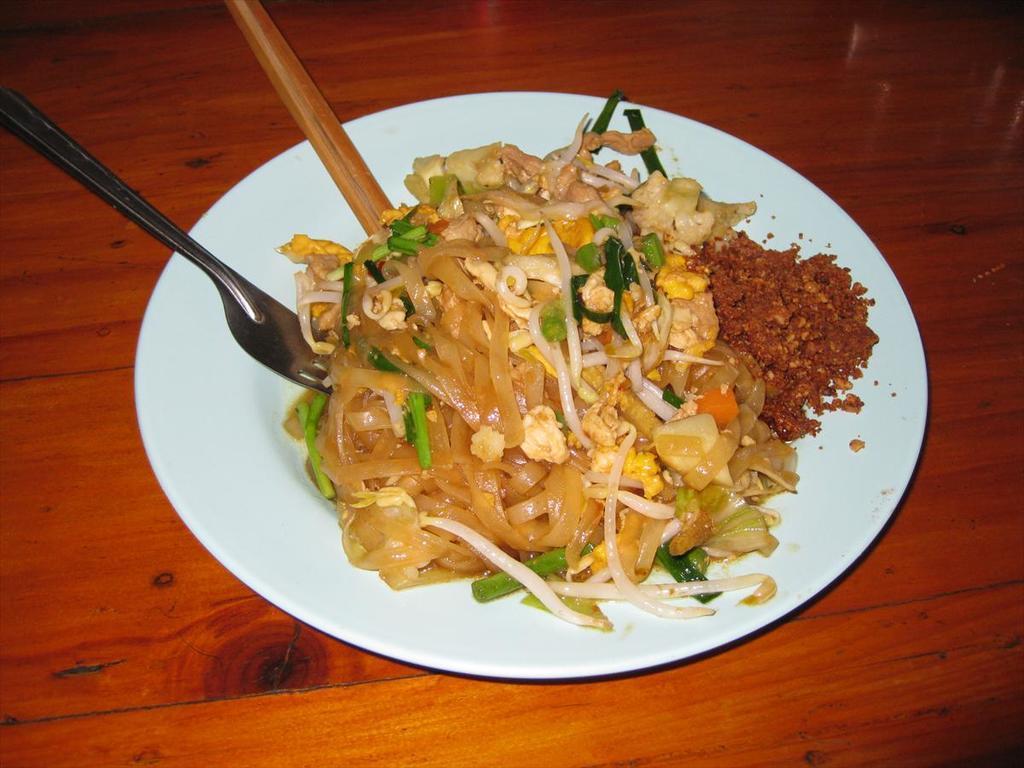Can you describe this image briefly? As we can see in the image, there is a fork, chopstick, fast food on plate and the plate is on table. 